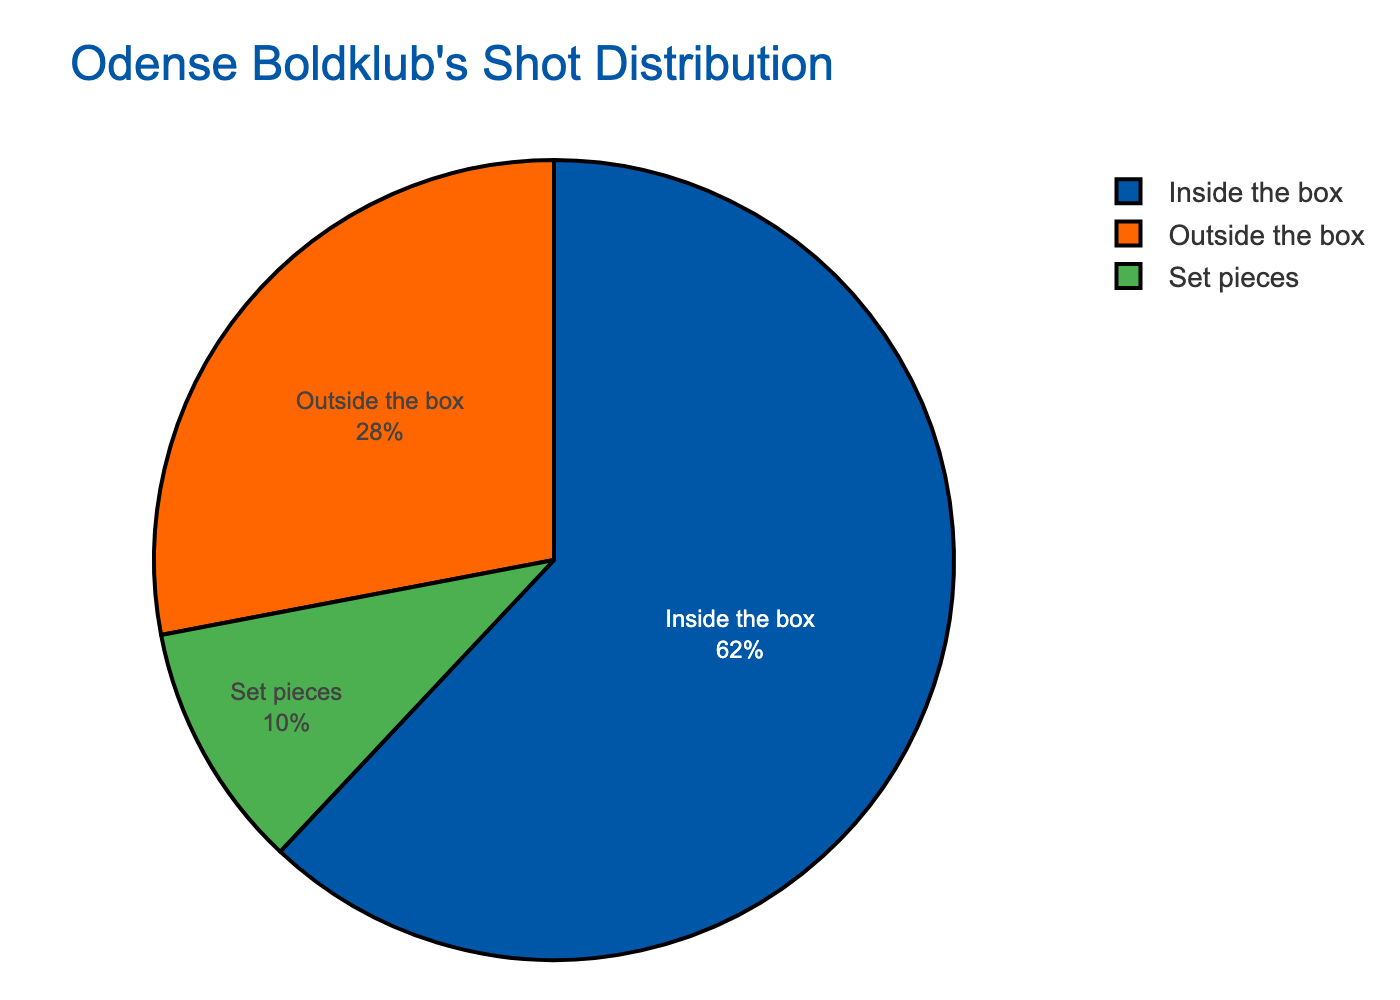What's the percentage of shots taken inside the box? The figure shows a pie chart with the zones and their respective percentages. The "Inside the box" section is labeled with 62%.
Answer: 62% How does the percentage of shots from set pieces compare to the percentage of shots outside the box? To find the relationship, compare the percentages directly. Shots from set pieces are 10%, while shots outside the box are 28%.
Answer: Less than If shots from inside the box and set pieces are combined, what percentage do they make up? Sum up the percentages of shots from inside the box (62%) and set pieces (10%) to get the combined percentage. 62 + 10 = 72.
Answer: 72% Which zone accounts for the smallest percentage of total shots? Observing the pie chart, the zone with the smallest angle and percentage is labeled as set pieces with 10%.
Answer: Set pieces What's the difference in percentage between shots taken inside the box and shots taken outside the box? Calculate the difference by subtracting the percentage of shots outside the box (28%) from the percentage of shots inside the box (62%). 62 - 28 = 34.
Answer: 34% What color represents the zone with the highest percentage of shots? The pie chart uses different colors for each zone, and the zone with the highest percentage (inside the box, 62%) is represented by blue.
Answer: Blue How much more frequent are shots from inside the box compared to those from set pieces (as a ratio)? Divide the percentage of shots inside the box (62%) by the percentage from set pieces (10%) to get the frequency ratio. 62 / 10 = 6.2.
Answer: 6.2 What is the average percentage of shots taken from outside the box and set pieces? Add the percentages of shots from outside the box (28%) and set pieces (10%), then divide by 2 to find the average. (28 + 10) / 2 = 19.
Answer: 19 If the total shots taken were 1000, how many shots were taken inside the box? Use the given percentage for shots inside the box (62%) to find the number out of 1000. 62% of 1000 is 0.62 * 1000 = 620.
Answer: 620 What is the percentage difference between the two closest zones in terms of shot percentage? Identify the two closest percentages, which are outside the box (28%) and set pieces (10%), then find the difference. 28 - 10 = 18.
Answer: 18% 